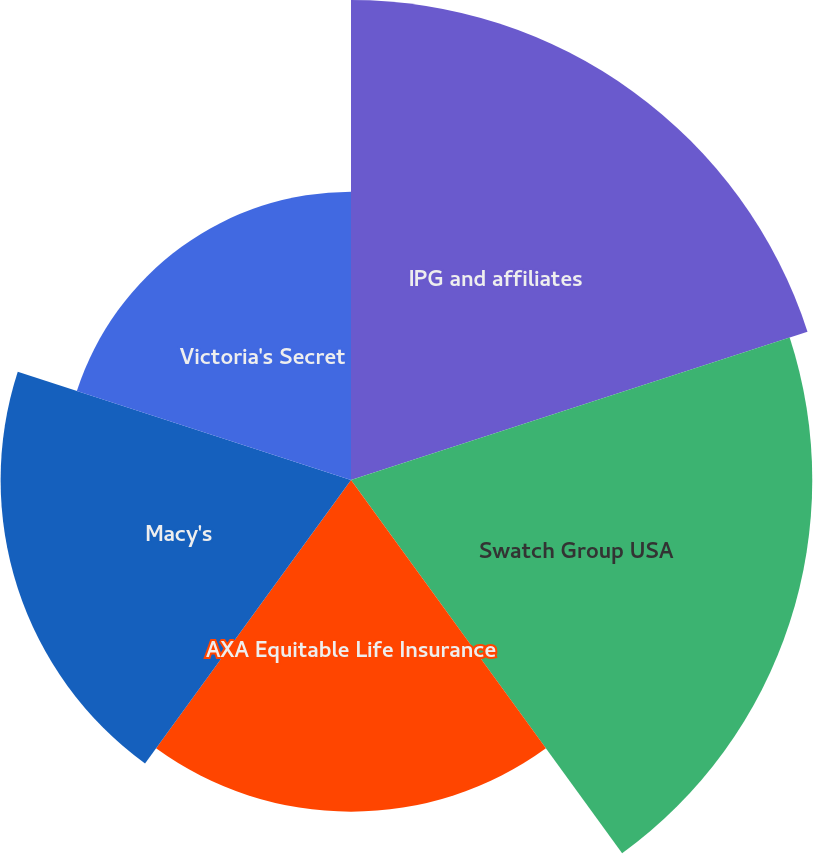Convert chart. <chart><loc_0><loc_0><loc_500><loc_500><pie_chart><fcel>IPG and affiliates<fcel>Swatch Group USA<fcel>AXA Equitable Life Insurance<fcel>Macy's<fcel>Victoria's Secret<nl><fcel>25.11%<fcel>24.13%<fcel>17.35%<fcel>18.33%<fcel>15.08%<nl></chart> 